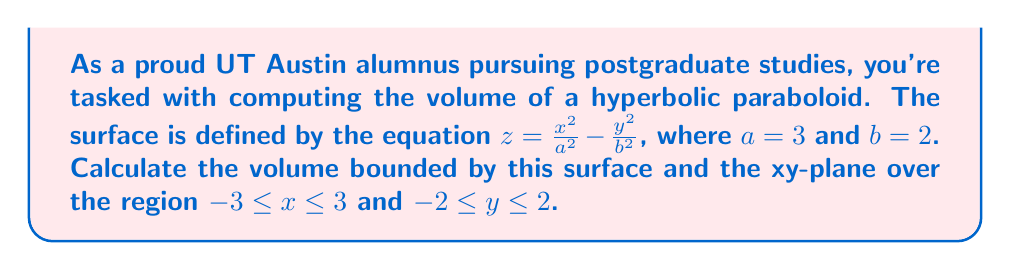Teach me how to tackle this problem. To solve this problem, we'll use a triple integral to calculate the volume. Let's break it down step-by-step:

1) The volume is given by the triple integral:

   $$V = \iiint_R dV = \int_{-3}^3 \int_{-2}^2 \int_0^{z(x,y)} dz dy dx$$

   where $z(x,y) = \frac{x^2}{9} - \frac{y^2}{4}$ (substituting $a=3$ and $b=2$)

2) First, let's integrate with respect to z:

   $$V = \int_{-3}^3 \int_{-2}^2 \left[z\right]_0^{\frac{x^2}{9} - \frac{y^2}{4}} dy dx$$

   $$V = \int_{-3}^3 \int_{-2}^2 \left(\frac{x^2}{9} - \frac{y^2}{4}\right) dy dx$$

3) Now, let's integrate with respect to y:

   $$V = \int_{-3}^3 \left[\frac{x^2}{9}y - \frac{y^3}{12}\right]_{-2}^2 dx$$

   $$V = \int_{-3}^3 \left(\frac{2x^2}{9} - \frac{8}{12} + \frac{2x^2}{9} - \frac{8}{12}\right) dx$$

   $$V = \int_{-3}^3 \left(\frac{4x^2}{9} - \frac{4}{3}\right) dx$$

4) Finally, let's integrate with respect to x:

   $$V = \left[\frac{4x^3}{27} - \frac{4x}{3}\right]_{-3}^3$$

   $$V = \left(\frac{4(27)}{27} - 4 + \frac{4(27)}{27} - 4\right)$$

   $$V = 8 - 8 = 0$$

5) Therefore, the volume is 0 cubic units.

This result makes sense geometrically. The hyperbolic paraboloid is saddle-shaped, extending both above and below the xy-plane. The volume above the xy-plane is exactly cancelled out by the volume below it within the given region.
Answer: The volume of the hyperbolic paraboloid bounded by $z = \frac{x^2}{9} - \frac{y^2}{4}$ and the xy-plane over the region $-3 \leq x \leq 3$ and $-2 \leq y \leq 2$ is 0 cubic units. 